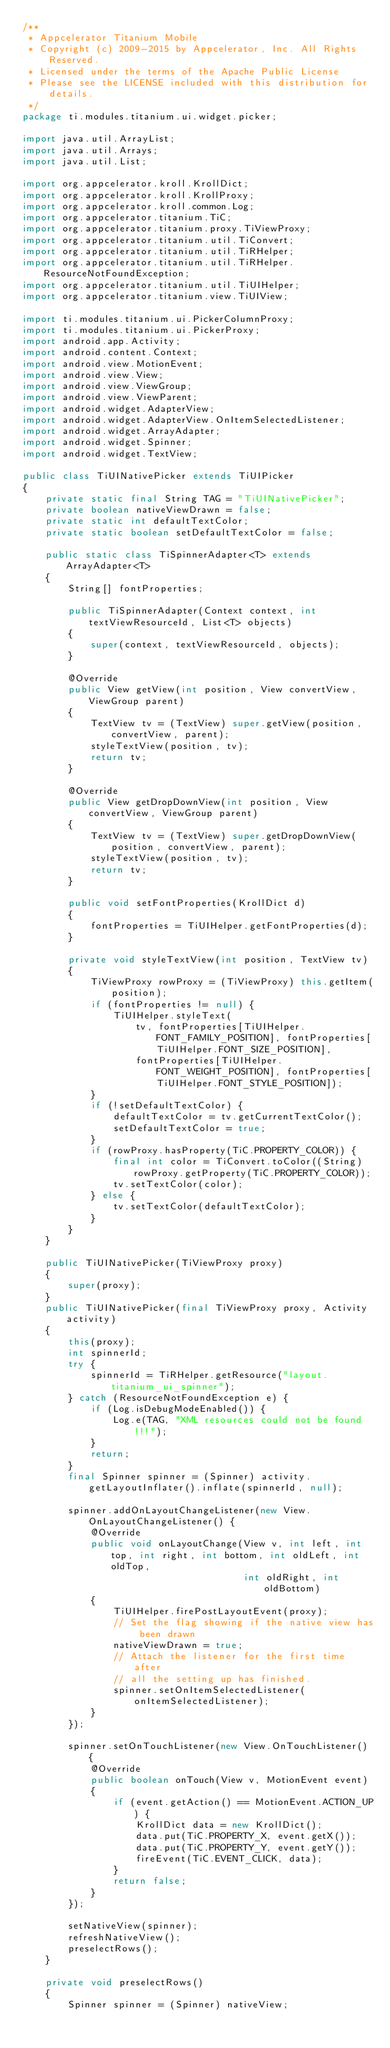Convert code to text. <code><loc_0><loc_0><loc_500><loc_500><_Java_>/**
 * Appcelerator Titanium Mobile
 * Copyright (c) 2009-2015 by Appcelerator, Inc. All Rights Reserved.
 * Licensed under the terms of the Apache Public License
 * Please see the LICENSE included with this distribution for details.
 */
package ti.modules.titanium.ui.widget.picker;

import java.util.ArrayList;
import java.util.Arrays;
import java.util.List;

import org.appcelerator.kroll.KrollDict;
import org.appcelerator.kroll.KrollProxy;
import org.appcelerator.kroll.common.Log;
import org.appcelerator.titanium.TiC;
import org.appcelerator.titanium.proxy.TiViewProxy;
import org.appcelerator.titanium.util.TiConvert;
import org.appcelerator.titanium.util.TiRHelper;
import org.appcelerator.titanium.util.TiRHelper.ResourceNotFoundException;
import org.appcelerator.titanium.util.TiUIHelper;
import org.appcelerator.titanium.view.TiUIView;

import ti.modules.titanium.ui.PickerColumnProxy;
import ti.modules.titanium.ui.PickerProxy;
import android.app.Activity;
import android.content.Context;
import android.view.MotionEvent;
import android.view.View;
import android.view.ViewGroup;
import android.view.ViewParent;
import android.widget.AdapterView;
import android.widget.AdapterView.OnItemSelectedListener;
import android.widget.ArrayAdapter;
import android.widget.Spinner;
import android.widget.TextView;

public class TiUINativePicker extends TiUIPicker
{
	private static final String TAG = "TiUINativePicker";
	private boolean nativeViewDrawn = false;
	private static int defaultTextColor;
	private static boolean setDefaultTextColor = false;

	public static class TiSpinnerAdapter<T> extends ArrayAdapter<T>
	{
		String[] fontProperties;

		public TiSpinnerAdapter(Context context, int textViewResourceId, List<T> objects)
		{
			super(context, textViewResourceId, objects);
		}

		@Override
		public View getView(int position, View convertView, ViewGroup parent)
		{
			TextView tv = (TextView) super.getView(position, convertView, parent);
			styleTextView(position, tv);
			return tv;
		}

		@Override
		public View getDropDownView(int position, View convertView, ViewGroup parent)
		{
			TextView tv = (TextView) super.getDropDownView(position, convertView, parent);
			styleTextView(position, tv);
			return tv;
		}

		public void setFontProperties(KrollDict d)
		{
			fontProperties = TiUIHelper.getFontProperties(d);
		}

		private void styleTextView(int position, TextView tv)
		{
			TiViewProxy rowProxy = (TiViewProxy) this.getItem(position);
			if (fontProperties != null) {
				TiUIHelper.styleText(
					tv, fontProperties[TiUIHelper.FONT_FAMILY_POSITION], fontProperties[TiUIHelper.FONT_SIZE_POSITION],
					fontProperties[TiUIHelper.FONT_WEIGHT_POSITION], fontProperties[TiUIHelper.FONT_STYLE_POSITION]);
			}
			if (!setDefaultTextColor) {
				defaultTextColor = tv.getCurrentTextColor();
				setDefaultTextColor = true;
			}
			if (rowProxy.hasProperty(TiC.PROPERTY_COLOR)) {
				final int color = TiConvert.toColor((String) rowProxy.getProperty(TiC.PROPERTY_COLOR));
				tv.setTextColor(color);
			} else {
				tv.setTextColor(defaultTextColor);
			}
		}
	}

	public TiUINativePicker(TiViewProxy proxy)
	{
		super(proxy);
	}
	public TiUINativePicker(final TiViewProxy proxy, Activity activity)
	{
		this(proxy);
		int spinnerId;
		try {
			spinnerId = TiRHelper.getResource("layout.titanium_ui_spinner");
		} catch (ResourceNotFoundException e) {
			if (Log.isDebugModeEnabled()) {
				Log.e(TAG, "XML resources could not be found!!!");
			}
			return;
		}
		final Spinner spinner = (Spinner) activity.getLayoutInflater().inflate(spinnerId, null);

		spinner.addOnLayoutChangeListener(new View.OnLayoutChangeListener() {
			@Override
			public void onLayoutChange(View v, int left, int top, int right, int bottom, int oldLeft, int oldTop,
									   int oldRight, int oldBottom)
			{
				TiUIHelper.firePostLayoutEvent(proxy);
				// Set the flag showing if the native view has been drawn
				nativeViewDrawn = true;
				// Attach the listener for the first time after
				// all the setting up has finished.
				spinner.setOnItemSelectedListener(onItemSelectedListener);
			}
		});

		spinner.setOnTouchListener(new View.OnTouchListener() {
			@Override
			public boolean onTouch(View v, MotionEvent event)
			{
				if (event.getAction() == MotionEvent.ACTION_UP) {
					KrollDict data = new KrollDict();
					data.put(TiC.PROPERTY_X, event.getX());
					data.put(TiC.PROPERTY_Y, event.getY());
					fireEvent(TiC.EVENT_CLICK, data);
				}
				return false;
			}
		});

		setNativeView(spinner);
		refreshNativeView();
		preselectRows();
	}

	private void preselectRows()
	{
		Spinner spinner = (Spinner) nativeView;</code> 